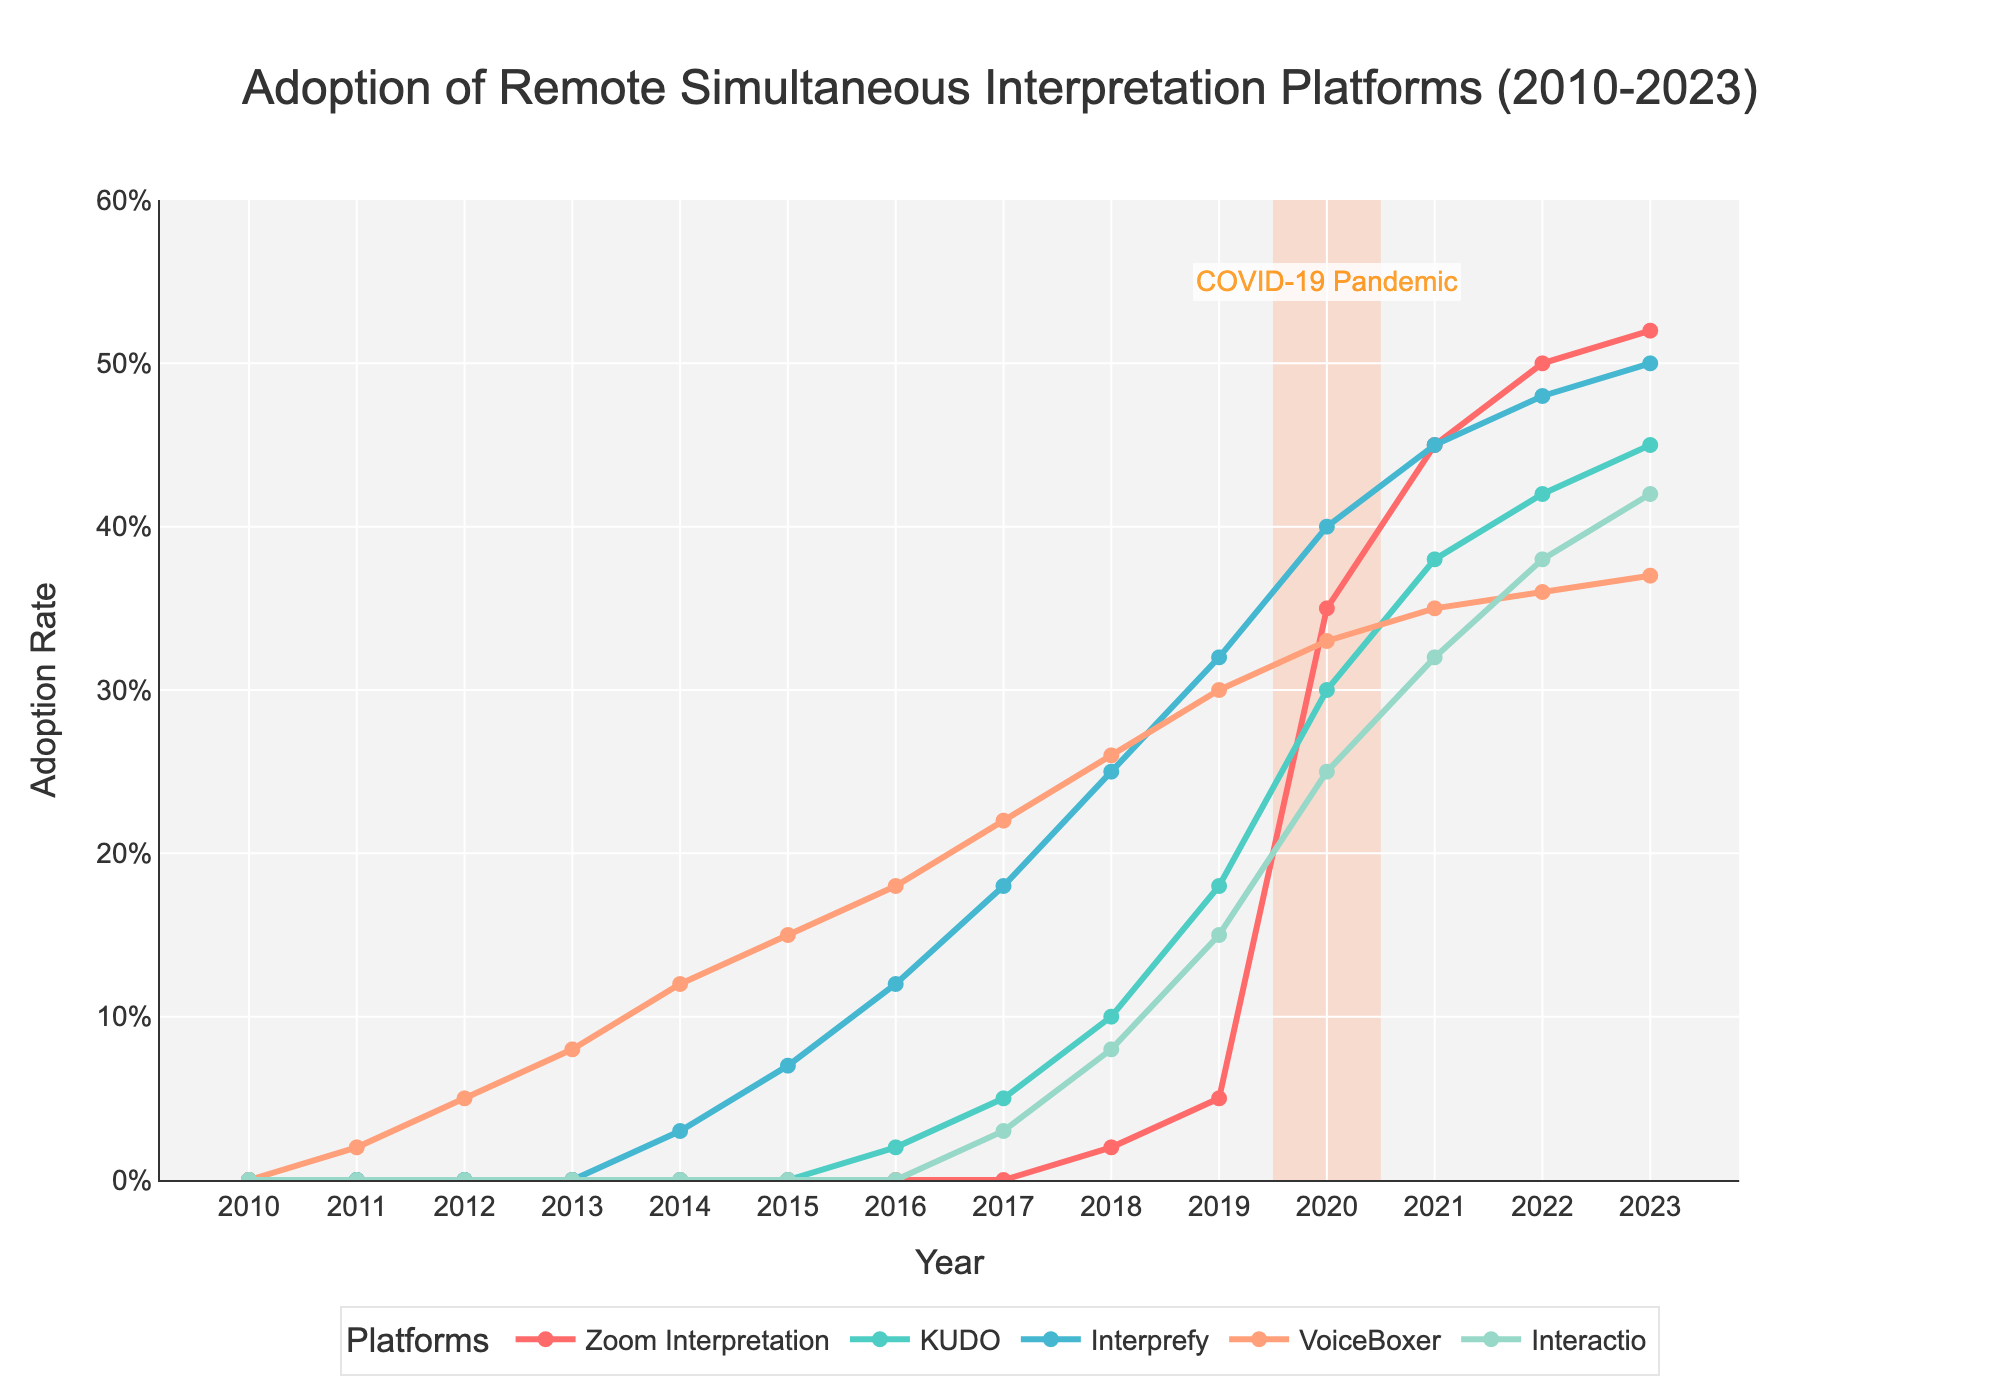Which platform saw the largest increase in adoption rate from 2019 to 2020? To find the platform with the largest increase, we need to compare the adoption rates of all platforms in 2019 and 2020. The differences are: Zoom Interpretation (30%), KUDO (12%), Interprefy (8%), VoiceBoxer (3%), Interactio (10%). The largest increase is 30% for Zoom Interpretation.
Answer: Zoom Interpretation In which year did Interactio's adoption rate exceed 20% for the first time? Looking at the data, Interactio's adoption rate first exceeds 20% in the year 2020 with an adoption rate of 25%.
Answer: 2020 How many platforms had an adoption rate above 35% in 2021? For the year 2021, the platforms with adoption rates above 35% are Zoom Interpretation (45%), KUDO (38%), and Interprefy (45%). So, three platforms met the criterion.
Answer: 3 Which platform had the least adoption rate in 2015? By checking the adoption rates for 2015, the least rate was for Zoom Interpretation and KUDO, both having 0%.
Answer: Zoom Interpretation and KUDO What was the average adoption rate of Interprefy from 2010 to 2013? The adoption rates for Interprefy from 2010 to 2013 are all 0%. Adding these and dividing by 4 gives an average of 0%.
Answer: 0% Compare the trends of VoiceBoxer and Interprefy between 2013 and 2017. Which one shows a steeper increase? Between 2013 and 2017, VoiceBoxer increased from 8% to 22%, a 14 percentage point increase. Interprefy increased from 0% to 18%, an 18 percentage point increase. Thus, Interprefy shows a steeper increase.
Answer: Interprefy In 2023, how much higher is the adoption rate of Zoom Interpretation compared to VoiceBoxer? The adoption rate of Zoom Interpretation in 2023 is 52% and VoiceBoxer is 37%. The difference is 52% - 37% = 15%.
Answer: 15% What is the total sum of adoption rates for all platforms in 2020? Adding the adoption rates of all platforms in 2020: Zoom Interpretation (35%), KUDO (30%), Interprefy (40%), VoiceBoxer (33%), Interactio (25%), gives a total of 163%.
Answer: 163% What's the overall trend for the adoption rate of remote simultaneous interpretation platforms from 2010 to 2023? By examining the data, all platforms generally show an upward trend in adoption rates over the years, with a significant spike around 2020.
Answer: Upward trend with a spike around 2020 